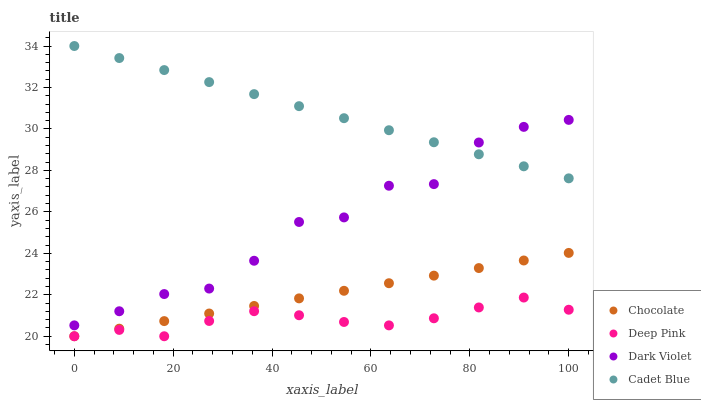Does Deep Pink have the minimum area under the curve?
Answer yes or no. Yes. Does Cadet Blue have the maximum area under the curve?
Answer yes or no. Yes. Does Dark Violet have the minimum area under the curve?
Answer yes or no. No. Does Dark Violet have the maximum area under the curve?
Answer yes or no. No. Is Chocolate the smoothest?
Answer yes or no. Yes. Is Dark Violet the roughest?
Answer yes or no. Yes. Is Deep Pink the smoothest?
Answer yes or no. No. Is Deep Pink the roughest?
Answer yes or no. No. Does Deep Pink have the lowest value?
Answer yes or no. Yes. Does Dark Violet have the lowest value?
Answer yes or no. No. Does Cadet Blue have the highest value?
Answer yes or no. Yes. Does Dark Violet have the highest value?
Answer yes or no. No. Is Deep Pink less than Cadet Blue?
Answer yes or no. Yes. Is Cadet Blue greater than Deep Pink?
Answer yes or no. Yes. Does Deep Pink intersect Chocolate?
Answer yes or no. Yes. Is Deep Pink less than Chocolate?
Answer yes or no. No. Is Deep Pink greater than Chocolate?
Answer yes or no. No. Does Deep Pink intersect Cadet Blue?
Answer yes or no. No. 